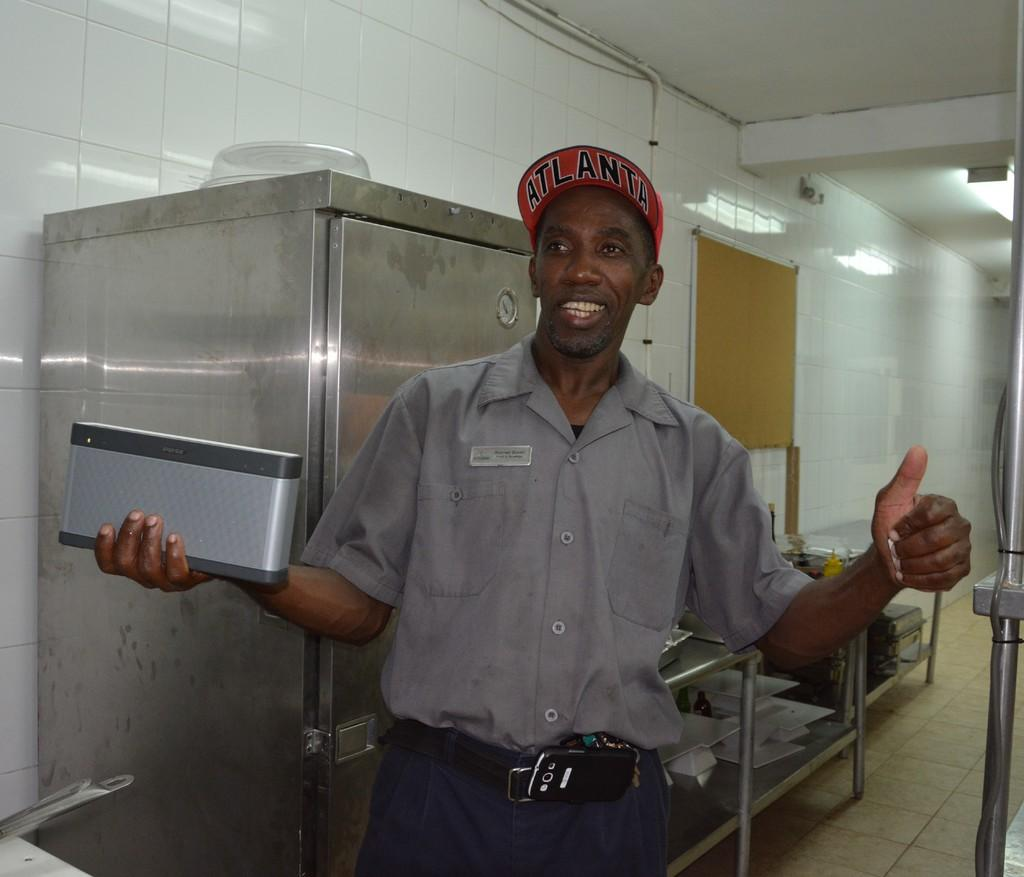<image>
Present a compact description of the photo's key features. A black man wearing a red Altanta hat gives a thumbs up with his left hand. 